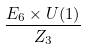Convert formula to latex. <formula><loc_0><loc_0><loc_500><loc_500>\frac { E _ { 6 } \times U ( 1 ) } { { Z } _ { 3 } }</formula> 